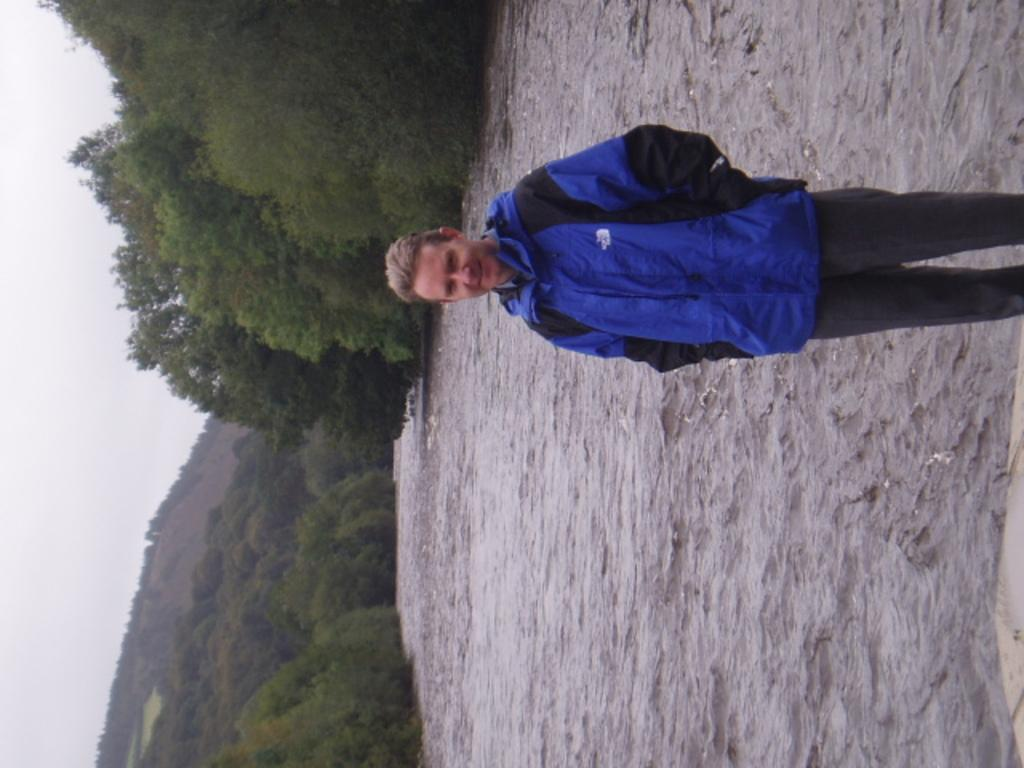Who or what is present in the image? There is a person in the image. What type of natural environment is depicted in the image? A: There are many trees and a lake visible in the image, suggesting a natural setting. What can be seen in the sky in the image? The sky is visible in the image. What type of landscape feature is present in the image? There is a hill in the image. What type of building can be seen in the image? There is no building present in the image; it features a person in a natural setting with trees, a lake, and a hill. How many legs does the person have in the image? The person in the image has two legs, as is typical for humans. 